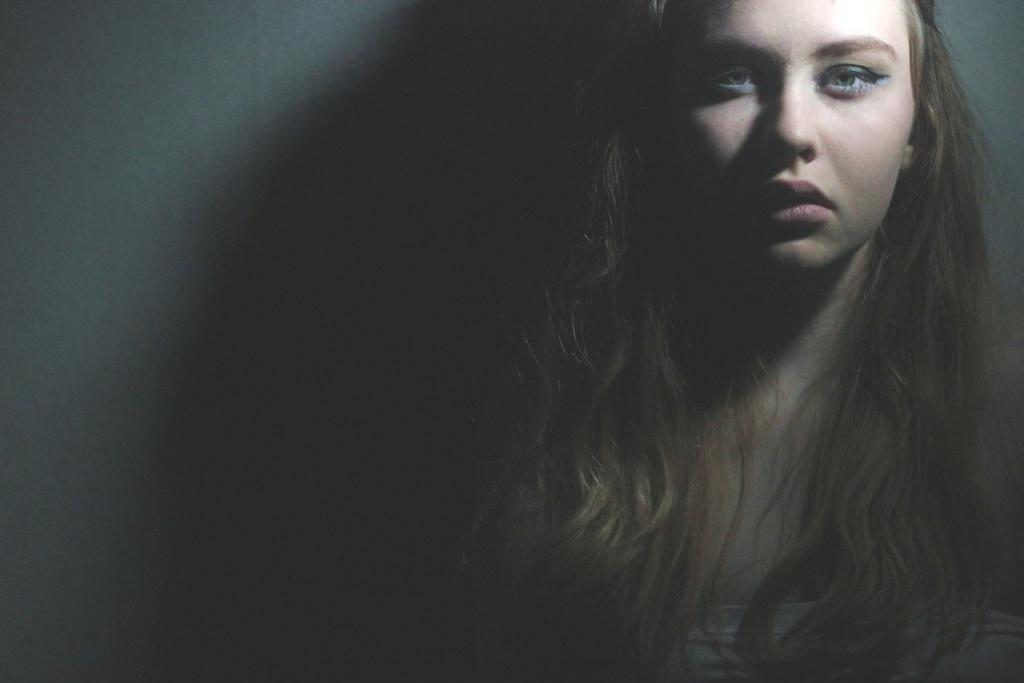Describe this image in one or two sentences. This image is taken in the dark where we can see a woman is standing near the wall. 